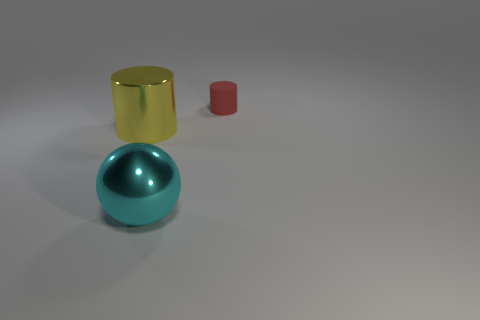Could you describe the lighting and the atmosphere that the image conveys? The image seems to capture a tranquil and minimalist setting, with a soft diffused light that creates gentle shadows, enhancing the three-dimensional appearance of the objects against the plain background. 